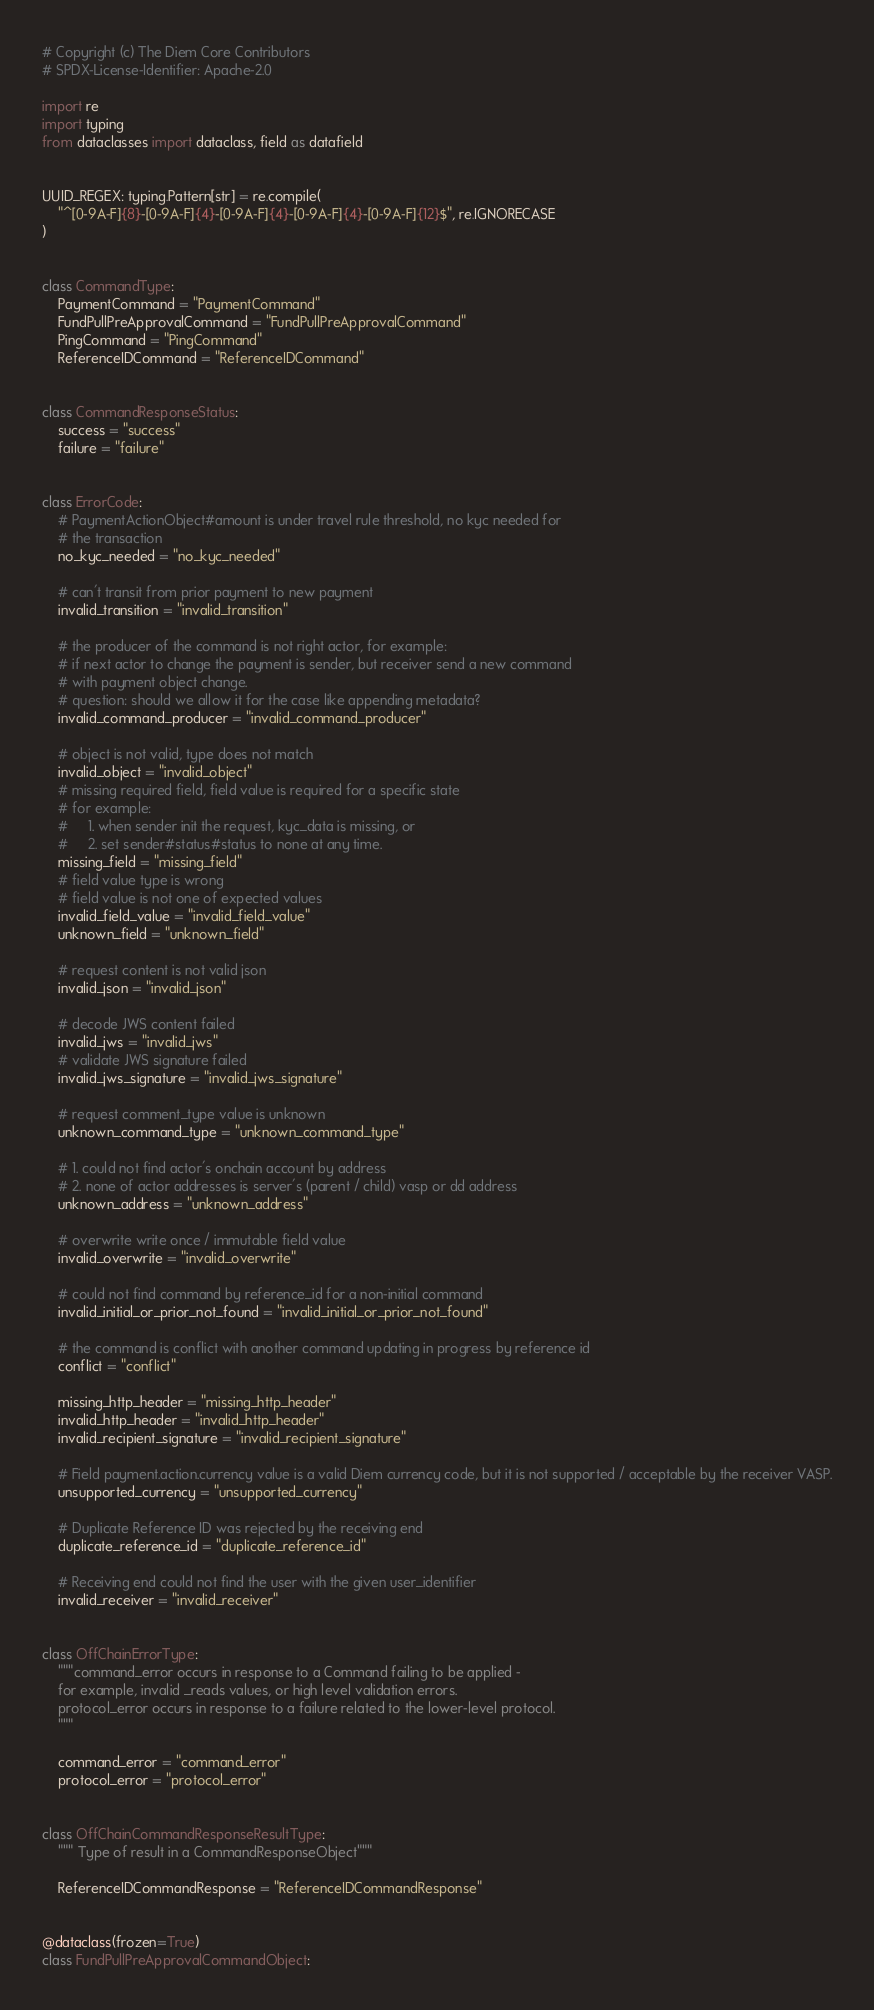Convert code to text. <code><loc_0><loc_0><loc_500><loc_500><_Python_># Copyright (c) The Diem Core Contributors
# SPDX-License-Identifier: Apache-2.0

import re
import typing
from dataclasses import dataclass, field as datafield


UUID_REGEX: typing.Pattern[str] = re.compile(
    "^[0-9A-F]{8}-[0-9A-F]{4}-[0-9A-F]{4}-[0-9A-F]{4}-[0-9A-F]{12}$", re.IGNORECASE
)


class CommandType:
    PaymentCommand = "PaymentCommand"
    FundPullPreApprovalCommand = "FundPullPreApprovalCommand"
    PingCommand = "PingCommand"
    ReferenceIDCommand = "ReferenceIDCommand"


class CommandResponseStatus:
    success = "success"
    failure = "failure"


class ErrorCode:
    # PaymentActionObject#amount is under travel rule threshold, no kyc needed for
    # the transaction
    no_kyc_needed = "no_kyc_needed"

    # can't transit from prior payment to new payment
    invalid_transition = "invalid_transition"

    # the producer of the command is not right actor, for example:
    # if next actor to change the payment is sender, but receiver send a new command
    # with payment object change.
    # question: should we allow it for the case like appending metadata?
    invalid_command_producer = "invalid_command_producer"

    # object is not valid, type does not match
    invalid_object = "invalid_object"
    # missing required field, field value is required for a specific state
    # for example:
    #     1. when sender init the request, kyc_data is missing, or
    #     2. set sender#status#status to none at any time.
    missing_field = "missing_field"
    # field value type is wrong
    # field value is not one of expected values
    invalid_field_value = "invalid_field_value"
    unknown_field = "unknown_field"

    # request content is not valid json
    invalid_json = "invalid_json"

    # decode JWS content failed
    invalid_jws = "invalid_jws"
    # validate JWS signature failed
    invalid_jws_signature = "invalid_jws_signature"

    # request comment_type value is unknown
    unknown_command_type = "unknown_command_type"

    # 1. could not find actor's onchain account by address
    # 2. none of actor addresses is server's (parent / child) vasp or dd address
    unknown_address = "unknown_address"

    # overwrite write once / immutable field value
    invalid_overwrite = "invalid_overwrite"

    # could not find command by reference_id for a non-initial command
    invalid_initial_or_prior_not_found = "invalid_initial_or_prior_not_found"

    # the command is conflict with another command updating in progress by reference id
    conflict = "conflict"

    missing_http_header = "missing_http_header"
    invalid_http_header = "invalid_http_header"
    invalid_recipient_signature = "invalid_recipient_signature"

    # Field payment.action.currency value is a valid Diem currency code, but it is not supported / acceptable by the receiver VASP.
    unsupported_currency = "unsupported_currency"

    # Duplicate Reference ID was rejected by the receiving end
    duplicate_reference_id = "duplicate_reference_id"

    # Receiving end could not find the user with the given user_identifier
    invalid_receiver = "invalid_receiver"


class OffChainErrorType:
    """command_error occurs in response to a Command failing to be applied -
    for example, invalid _reads values, or high level validation errors.
    protocol_error occurs in response to a failure related to the lower-level protocol.
    """

    command_error = "command_error"
    protocol_error = "protocol_error"


class OffChainCommandResponseResultType:
    """ Type of result in a CommandResponseObject"""

    ReferenceIDCommandResponse = "ReferenceIDCommandResponse"


@dataclass(frozen=True)
class FundPullPreApprovalCommandObject:</code> 